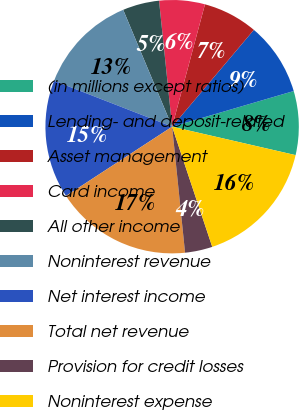<chart> <loc_0><loc_0><loc_500><loc_500><pie_chart><fcel>(in millions except ratios)<fcel>Lending- and deposit-related<fcel>Asset management<fcel>Card income<fcel>All other income<fcel>Noninterest revenue<fcel>Net interest income<fcel>Total net revenue<fcel>Provision for credit losses<fcel>Noninterest expense<nl><fcel>8.14%<fcel>9.3%<fcel>6.98%<fcel>5.82%<fcel>4.66%<fcel>12.78%<fcel>15.1%<fcel>17.42%<fcel>3.5%<fcel>16.26%<nl></chart> 